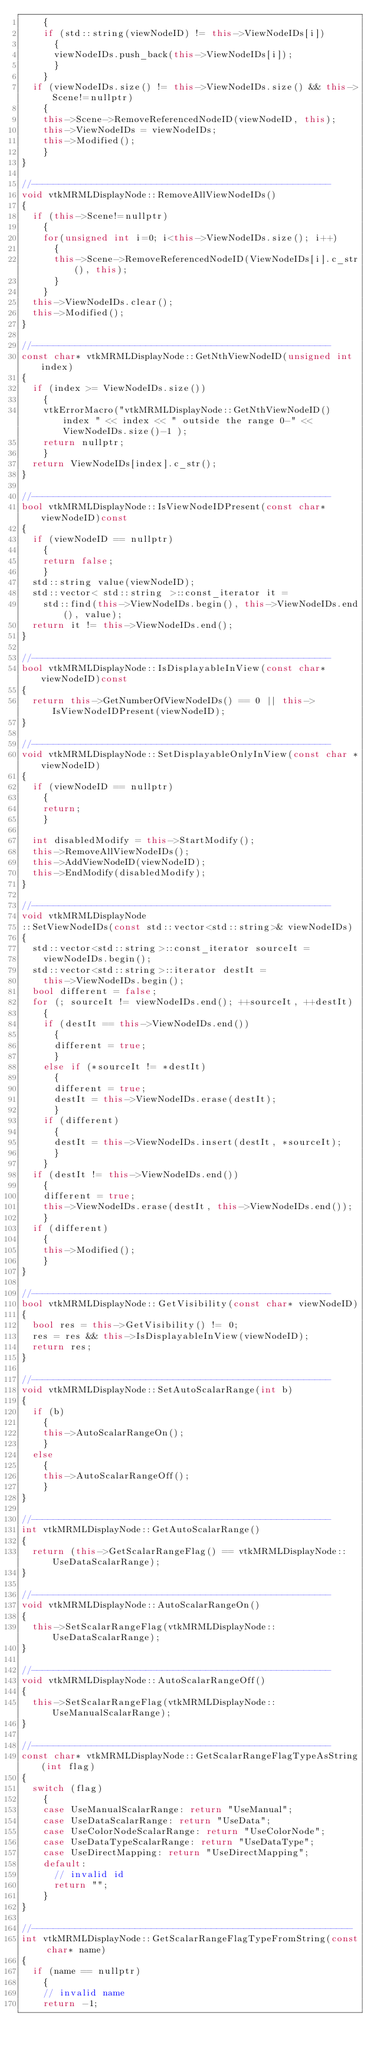<code> <loc_0><loc_0><loc_500><loc_500><_C++_>    {
    if (std::string(viewNodeID) != this->ViewNodeIDs[i])
      {
      viewNodeIDs.push_back(this->ViewNodeIDs[i]);
      }
    }
  if (viewNodeIDs.size() != this->ViewNodeIDs.size() && this->Scene!=nullptr)
    {
    this->Scene->RemoveReferencedNodeID(viewNodeID, this);
    this->ViewNodeIDs = viewNodeIDs;
    this->Modified();
    }
}

//-------------------------------------------------------
void vtkMRMLDisplayNode::RemoveAllViewNodeIDs()
{
  if (this->Scene!=nullptr)
    {
    for(unsigned int i=0; i<this->ViewNodeIDs.size(); i++)
      {
      this->Scene->RemoveReferencedNodeID(ViewNodeIDs[i].c_str(), this);
      }
    }
  this->ViewNodeIDs.clear();
  this->Modified();
}

//-------------------------------------------------------
const char* vtkMRMLDisplayNode::GetNthViewNodeID(unsigned int index)
{
  if (index >= ViewNodeIDs.size())
    {
    vtkErrorMacro("vtkMRMLDisplayNode::GetNthViewNodeID() index " << index << " outside the range 0-" << ViewNodeIDs.size()-1 );
    return nullptr;
    }
  return ViewNodeIDs[index].c_str();
}

//-------------------------------------------------------
bool vtkMRMLDisplayNode::IsViewNodeIDPresent(const char* viewNodeID)const
{
  if (viewNodeID == nullptr)
    {
    return false;
    }
  std::string value(viewNodeID);
  std::vector< std::string >::const_iterator it =
    std::find(this->ViewNodeIDs.begin(), this->ViewNodeIDs.end(), value);
  return it != this->ViewNodeIDs.end();
}

//-------------------------------------------------------
bool vtkMRMLDisplayNode::IsDisplayableInView(const char* viewNodeID)const
{
  return this->GetNumberOfViewNodeIDs() == 0 || this->IsViewNodeIDPresent(viewNodeID);
}

//-------------------------------------------------------
void vtkMRMLDisplayNode::SetDisplayableOnlyInView(const char *viewNodeID)
{
  if (viewNodeID == nullptr)
    {
    return;
    }

  int disabledModify = this->StartModify();
  this->RemoveAllViewNodeIDs();
  this->AddViewNodeID(viewNodeID);
  this->EndModify(disabledModify);
}

//-------------------------------------------------------
void vtkMRMLDisplayNode
::SetViewNodeIDs(const std::vector<std::string>& viewNodeIDs)
{
  std::vector<std::string>::const_iterator sourceIt =
    viewNodeIDs.begin();
  std::vector<std::string>::iterator destIt =
    this->ViewNodeIDs.begin();
  bool different = false;
  for (; sourceIt != viewNodeIDs.end(); ++sourceIt, ++destIt)
    {
    if (destIt == this->ViewNodeIDs.end())
      {
      different = true;
      }
    else if (*sourceIt != *destIt)
      {
      different = true;
      destIt = this->ViewNodeIDs.erase(destIt);
      }
    if (different)
      {
      destIt = this->ViewNodeIDs.insert(destIt, *sourceIt);
      }
    }
  if (destIt != this->ViewNodeIDs.end())
    {
    different = true;
    this->ViewNodeIDs.erase(destIt, this->ViewNodeIDs.end());
    }
  if (different)
    {
    this->Modified();
    }
}

//-------------------------------------------------------
bool vtkMRMLDisplayNode::GetVisibility(const char* viewNodeID)
{
  bool res = this->GetVisibility() != 0;
  res = res && this->IsDisplayableInView(viewNodeID);
  return res;
}

//-------------------------------------------------------
void vtkMRMLDisplayNode::SetAutoScalarRange(int b)
{
  if (b)
    {
    this->AutoScalarRangeOn();
    }
  else
    {
    this->AutoScalarRangeOff();
    }
}

//-------------------------------------------------------
int vtkMRMLDisplayNode::GetAutoScalarRange()
{
  return (this->GetScalarRangeFlag() == vtkMRMLDisplayNode::UseDataScalarRange);
}

//-------------------------------------------------------
void vtkMRMLDisplayNode::AutoScalarRangeOn()
{
  this->SetScalarRangeFlag(vtkMRMLDisplayNode::UseDataScalarRange);
}

//-------------------------------------------------------
void vtkMRMLDisplayNode::AutoScalarRangeOff()
{
  this->SetScalarRangeFlag(vtkMRMLDisplayNode::UseManualScalarRange);
}

//-------------------------------------------------------
const char* vtkMRMLDisplayNode::GetScalarRangeFlagTypeAsString(int flag)
{
  switch (flag)
    {
    case UseManualScalarRange: return "UseManual";
    case UseDataScalarRange: return "UseData";
    case UseColorNodeScalarRange: return "UseColorNode";
    case UseDataTypeScalarRange: return "UseDataType";
    case UseDirectMapping: return "UseDirectMapping";
    default:
      // invalid id
      return "";
    }
}

//-----------------------------------------------------------
int vtkMRMLDisplayNode::GetScalarRangeFlagTypeFromString(const char* name)
{
  if (name == nullptr)
    {
    // invalid name
    return -1;</code> 